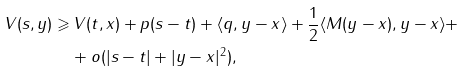Convert formula to latex. <formula><loc_0><loc_0><loc_500><loc_500>V ( s , y ) \geqslant & \, V ( t , x ) + p ( s - t ) + \langle q , y - x \rangle + \frac { 1 } { 2 } \langle M ( y - x ) , y - x \rangle + \\ & + o ( | s - t | + | y - x | ^ { 2 } ) ,</formula> 